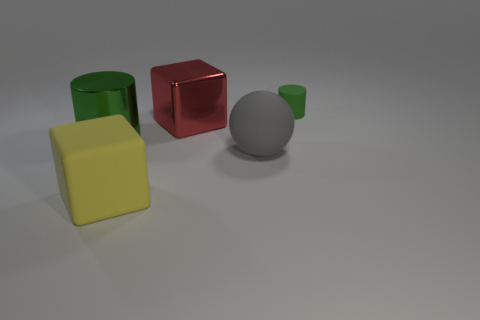Subtract all yellow blocks. How many blocks are left? 1 Subtract 2 cylinders. How many cylinders are left? 0 Add 1 large blue objects. How many objects exist? 6 Subtract all spheres. How many objects are left? 4 Subtract all red balls. Subtract all cyan blocks. How many balls are left? 1 Subtract all large blue spheres. Subtract all large yellow blocks. How many objects are left? 4 Add 1 big gray matte balls. How many big gray matte balls are left? 2 Add 1 yellow rubber things. How many yellow rubber things exist? 2 Subtract 0 green spheres. How many objects are left? 5 